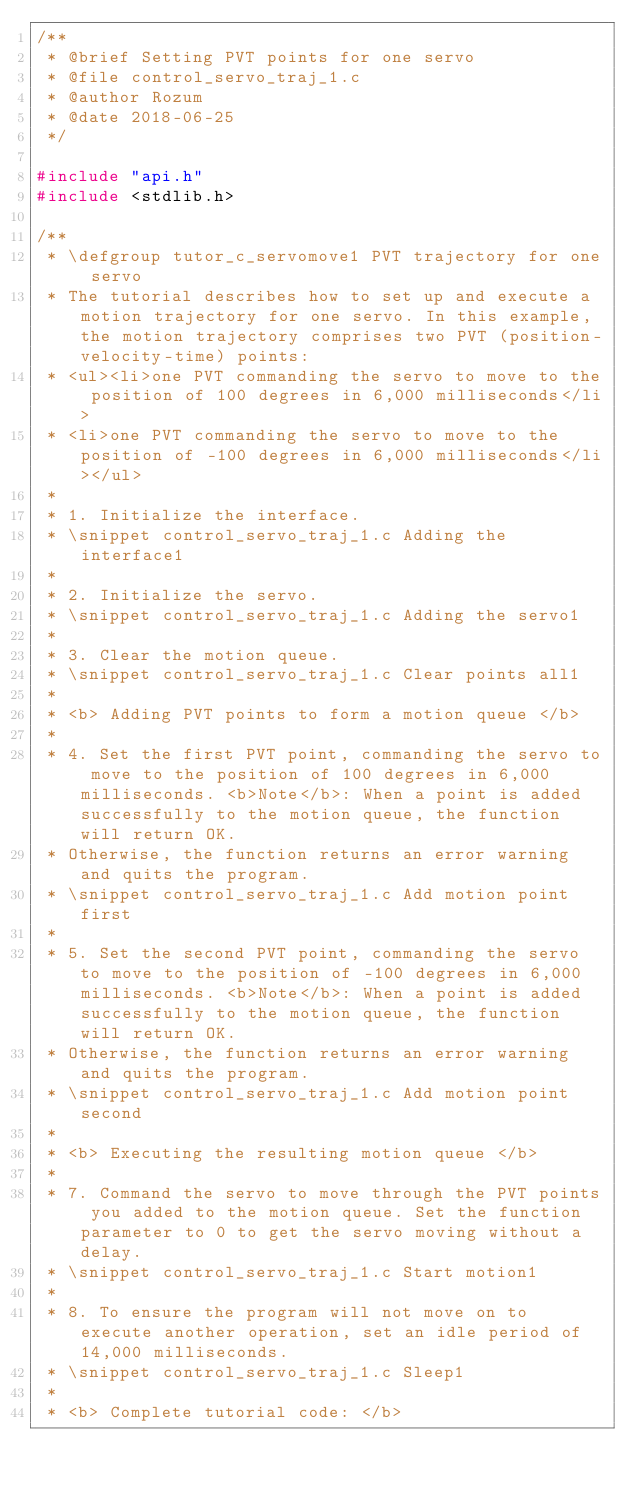<code> <loc_0><loc_0><loc_500><loc_500><_C_>/**
 * @brief Setting PVT points for one servo
 * @file control_servo_traj_1.c
 * @author Rozum
 * @date 2018-06-25
 */

#include "api.h"
#include <stdlib.h>

/**
 * \defgroup tutor_c_servomove1 PVT trajectory for one servo
 * The tutorial describes how to set up and execute a motion trajectory for one servo. In this example, the motion trajectory comprises two PVT (position-velocity-time) points:
 * <ul><li>one PVT commanding the servo to move to the position of 100 degrees in 6,000 milliseconds</li>
 * <li>one PVT commanding the servo to move to the position of -100 degrees in 6,000 milliseconds</li></ul>
 * 
 * 1. Initialize the interface.
 * \snippet control_servo_traj_1.c Adding the interface1
 * 
 * 2. Initialize the servo.
 * \snippet control_servo_traj_1.c Adding the servo1
 * 
 * 3. Clear the motion queue.
 * \snippet control_servo_traj_1.c Clear points all1
 * 
 * <b> Adding PVT points to form a motion queue </b>
 * 
 * 4. Set the first PVT point, commanding the servo to move to the position of 100 degrees in 6,000 milliseconds. <b>Note</b>: When a point is added successfully to the motion queue, the function will return OK.
 * Otherwise, the function returns an error warning and quits the program.
 * \snippet control_servo_traj_1.c Add motion point first
 * 
 * 5. Set the second PVT point, commanding the servo to move to the position of -100 degrees in 6,000 milliseconds. <b>Note</b>: When a point is added successfully to the motion queue, the function will return OK.
 * Otherwise, the function returns an error warning and quits the program.
 * \snippet control_servo_traj_1.c Add motion point second
 * 
 * <b> Executing the resulting motion queue </b>
 * 
 * 7. Command the servo to move through the PVT points you added to the motion queue. Set the function parameter to 0 to get the servo moving without a delay.
 * \snippet control_servo_traj_1.c Start motion1
 * 
 * 8. To ensure the program will not move on to execute another operation, set an idle period of 14,000 milliseconds.
 * \snippet control_servo_traj_1.c Sleep1
 * 
 * <b> Complete tutorial code: </b></code> 